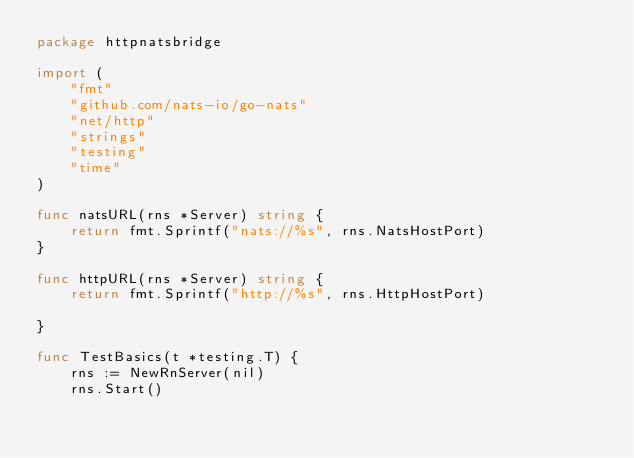Convert code to text. <code><loc_0><loc_0><loc_500><loc_500><_Go_>package httpnatsbridge

import (
	"fmt"
	"github.com/nats-io/go-nats"
	"net/http"
	"strings"
	"testing"
	"time"
)

func natsURL(rns *Server) string {
	return fmt.Sprintf("nats://%s", rns.NatsHostPort)
}

func httpURL(rns *Server) string {
	return fmt.Sprintf("http://%s", rns.HttpHostPort)

}

func TestBasics(t *testing.T) {
	rns := NewRnServer(nil)
	rns.Start()
</code> 